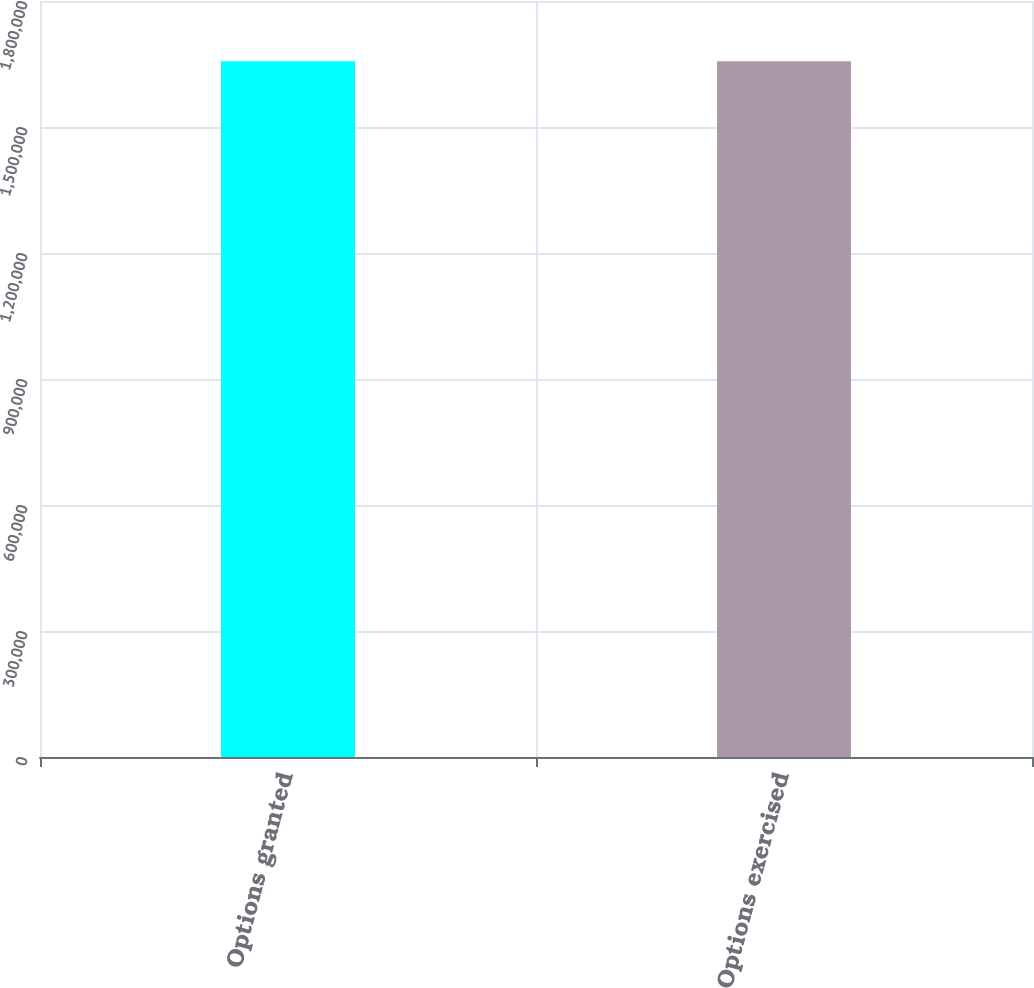<chart> <loc_0><loc_0><loc_500><loc_500><bar_chart><fcel>Options granted<fcel>Options exercised<nl><fcel>1.65655e+06<fcel>1.65655e+06<nl></chart> 